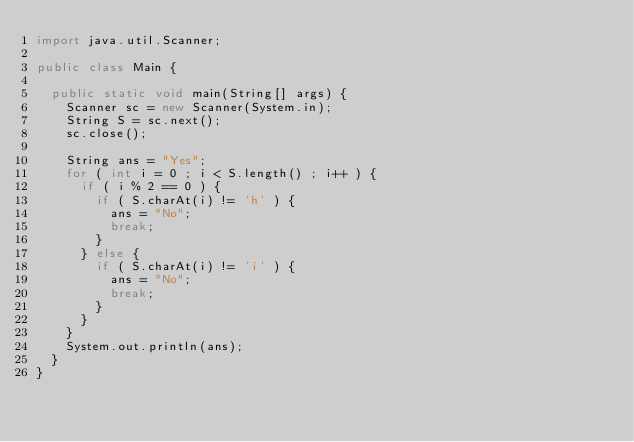<code> <loc_0><loc_0><loc_500><loc_500><_Java_>import java.util.Scanner;

public class Main {

	public static void main(String[] args) {
		Scanner sc = new Scanner(System.in);
		String S = sc.next();
		sc.close();

		String ans = "Yes";
		for ( int i = 0 ; i < S.length() ; i++ ) {
			if ( i % 2 == 0 ) {
				if ( S.charAt(i) != 'h' ) {
					ans = "No";
					break;
				}
			} else {
				if ( S.charAt(i) != 'i' ) {
					ans = "No";
					break;
				}
			}
		}
		System.out.println(ans);
	}
}
</code> 